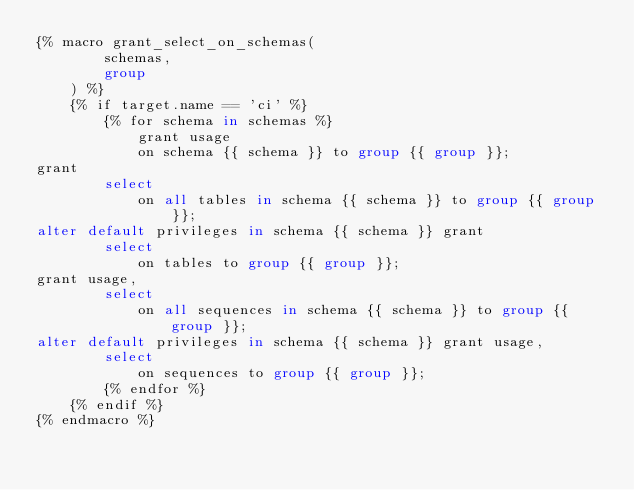Convert code to text. <code><loc_0><loc_0><loc_500><loc_500><_SQL_>{% macro grant_select_on_schemas(
        schemas,
        group
    ) %}
    {% if target.name == 'ci' %}
        {% for schema in schemas %}
            grant usage
            on schema {{ schema }} to group {{ group }};
grant
        select
            on all tables in schema {{ schema }} to group {{ group }};
alter default privileges in schema {{ schema }} grant
        select
            on tables to group {{ group }};
grant usage,
        select
            on all sequences in schema {{ schema }} to group {{ group }};
alter default privileges in schema {{ schema }} grant usage,
        select
            on sequences to group {{ group }};
        {% endfor %}
    {% endif %}
{% endmacro %}
</code> 